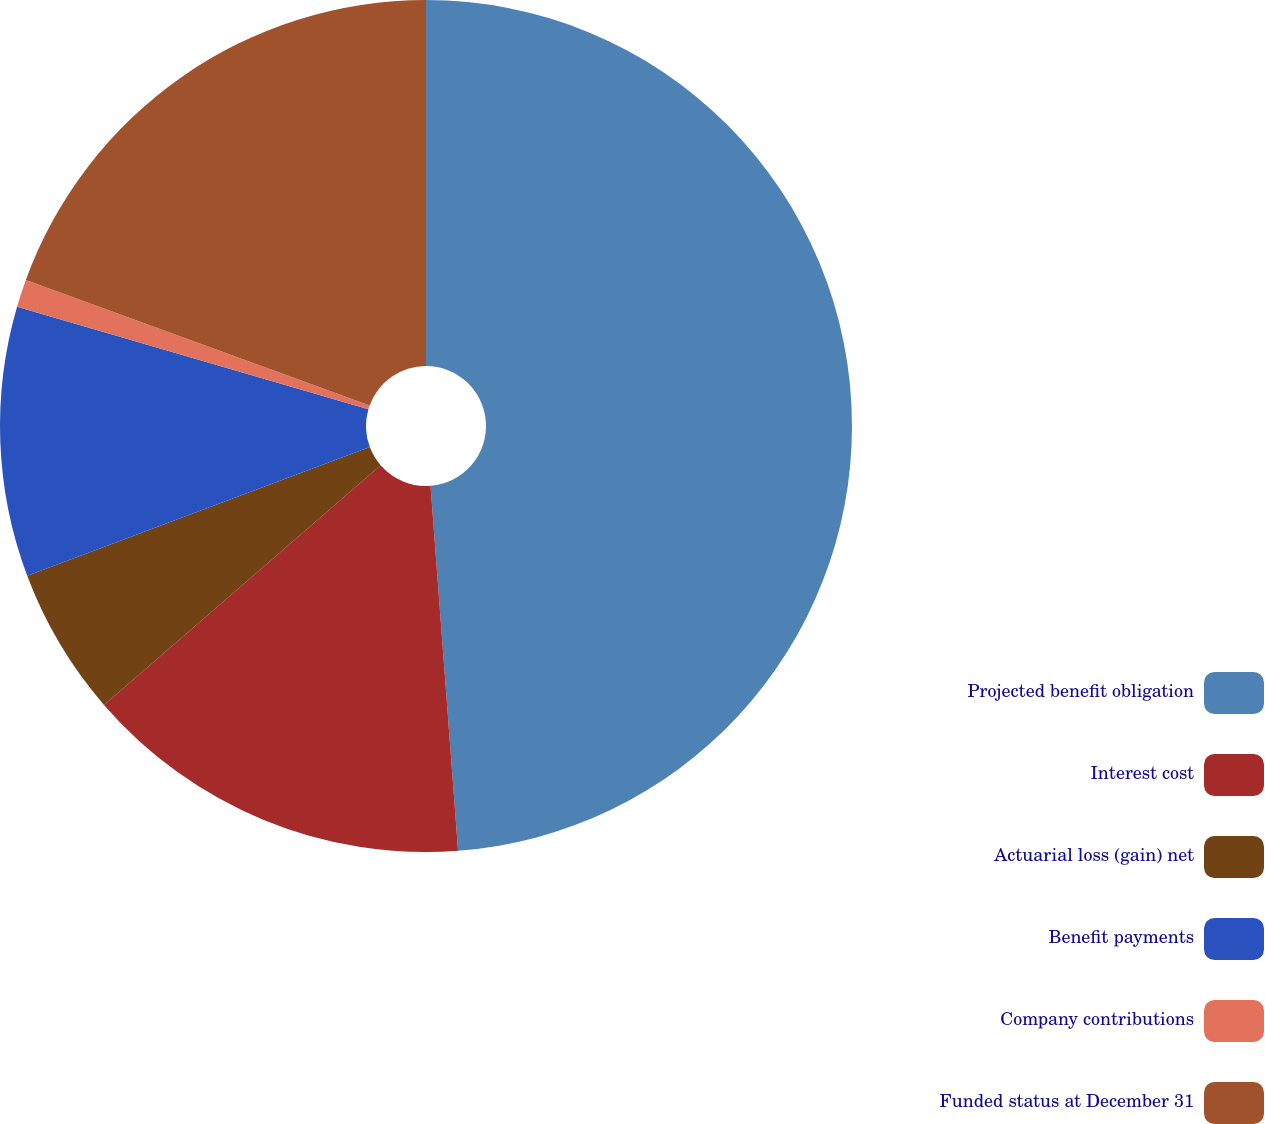Convert chart to OTSL. <chart><loc_0><loc_0><loc_500><loc_500><pie_chart><fcel>Projected benefit obligation<fcel>Interest cost<fcel>Actuarial loss (gain) net<fcel>Benefit payments<fcel>Company contributions<fcel>Funded status at December 31<nl><fcel>48.8%<fcel>14.84%<fcel>5.64%<fcel>10.24%<fcel>1.05%<fcel>19.43%<nl></chart> 